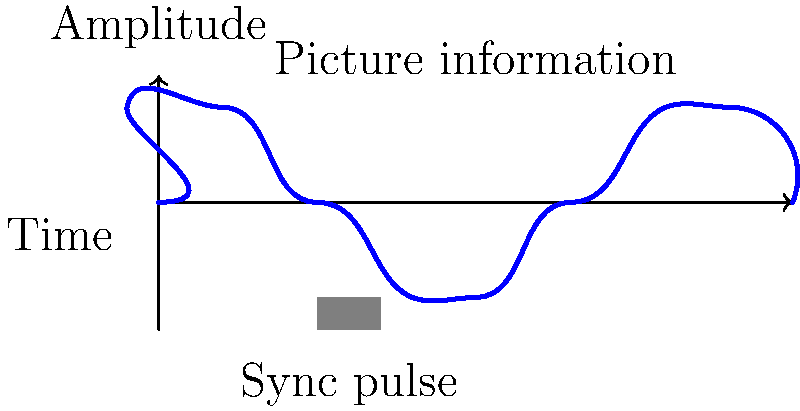In early television broadcasting, a specific waveform pattern was used to transmit both picture information and synchronization signals. Based on the waveform shown, which represents a single horizontal line scan, what does the negative-going pulse at the beginning of each line represent, and how does it relate to the formation of a coherent image on the television screen? To understand this waveform and its significance in early television broadcasting, let's break it down step-by-step:

1. The waveform represents a single horizontal line scan in a television signal.

2. The most prominent feature is the negative-going pulse at the beginning of the line. This is known as the horizontal sync pulse.

3. The sync pulse serves several crucial functions:
   a) It signals the end of one line and the beginning of the next.
   b) It triggers the television receiver to reset the electron beam to the left side of the screen.
   c) It ensures that the receiver stays in synchronization with the transmitter.

4. After the sync pulse, the waveform rises to represent the picture information for that particular line.

5. The varying amplitude of the waveform corresponds to the brightness of different points along the horizontal line on the screen.

6. This process repeats for each line of the image, typically 525 lines in the NTSC system used in North America and Japan, or 625 lines in the PAL system used in most of Europe and many other parts of the world.

7. The regular timing of these sync pulses ensures that each line of the image is displayed in the correct position on the screen, creating a coherent picture.

8. Without these sync pulses, the television receiver would not know when to start each new line, resulting in a distorted or unviewable image.

This waveform pattern demonstrates the ingenious way in which early television engineers solved the problem of transmitting both picture information and timing signals within a single channel, laying the groundwork for the development of television as a mass medium.
Answer: Horizontal sync pulse; ensures line-by-line synchronization for coherent image formation 